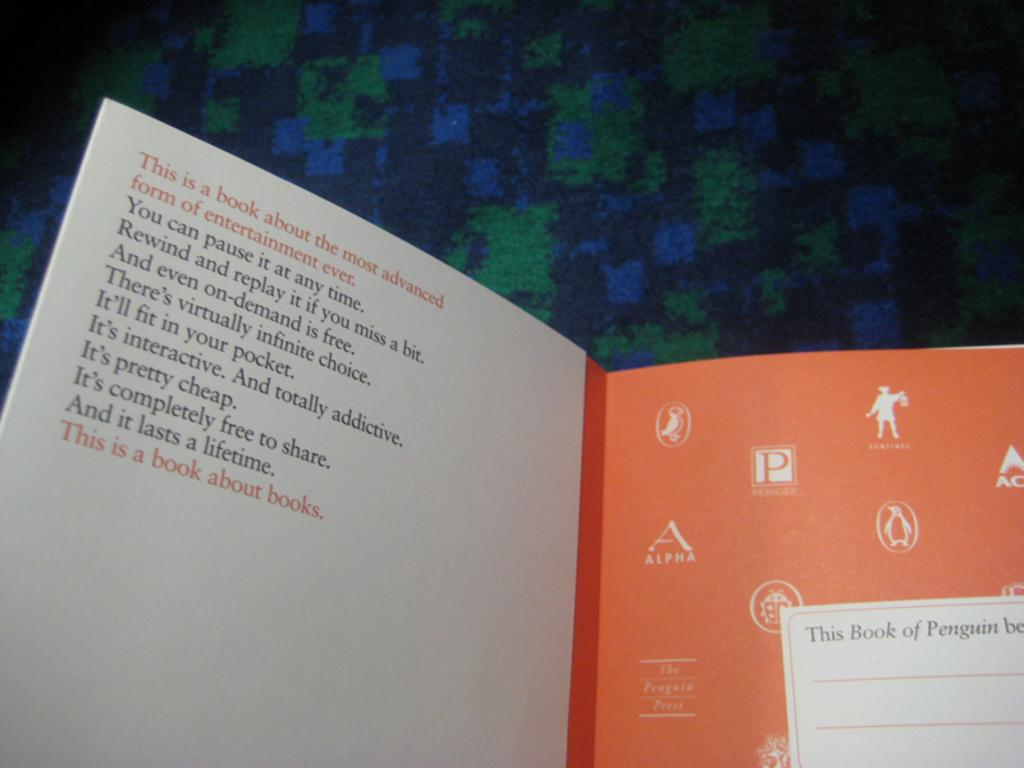<image>
Render a clear and concise summary of the photo. The text says that this book is about books. 